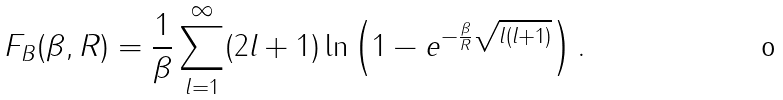<formula> <loc_0><loc_0><loc_500><loc_500>F _ { B } ( \beta , R ) = \frac { 1 } { \beta } \sum _ { l = 1 } ^ { \infty } ( 2 l + 1 ) \ln { \left ( 1 - e ^ { - \frac { \beta } { R } \sqrt { l ( l + 1 ) } } \right ) } \, .</formula> 